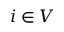Convert formula to latex. <formula><loc_0><loc_0><loc_500><loc_500>i \in V</formula> 